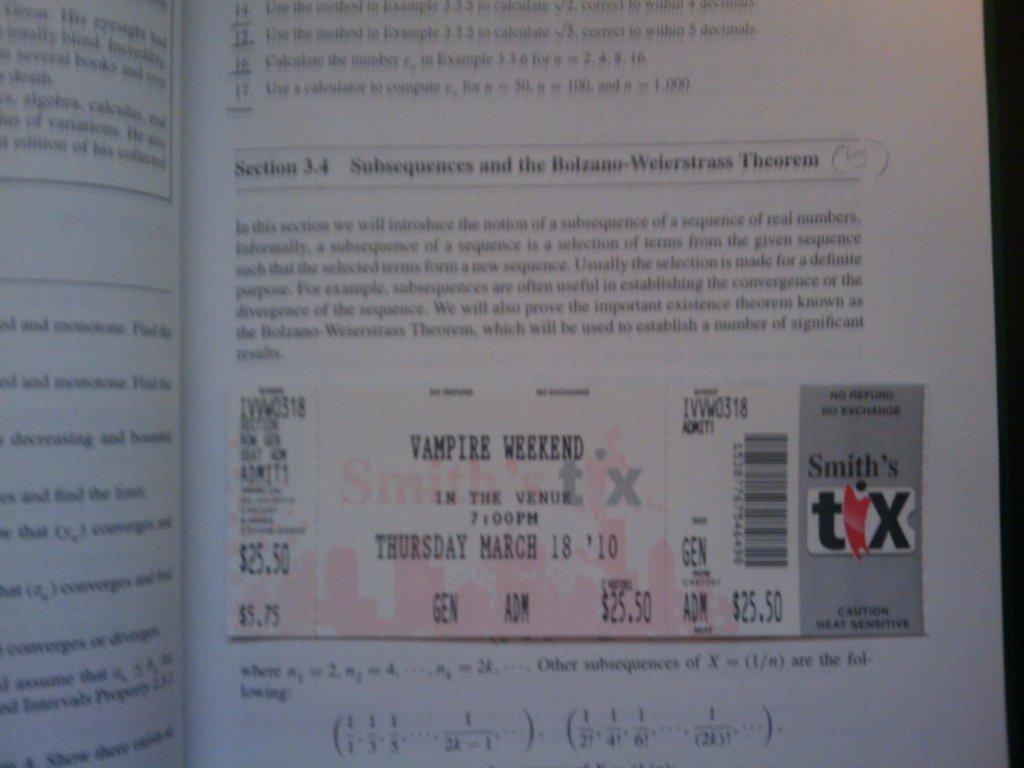<image>
Summarize the visual content of the image. A movie ticket for admittance to a Vampire Weekend 